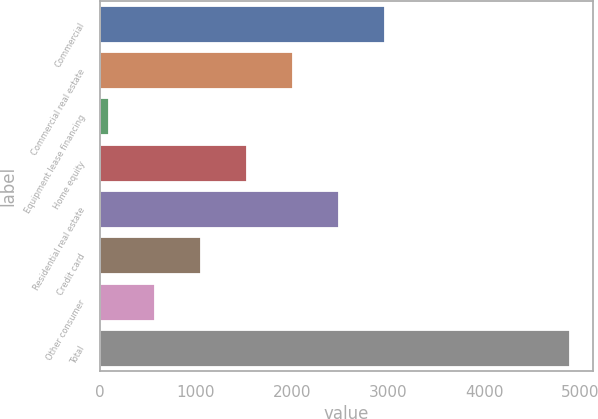Convert chart to OTSL. <chart><loc_0><loc_0><loc_500><loc_500><bar_chart><fcel>Commercial<fcel>Commercial real estate<fcel>Equipment lease financing<fcel>Home equity<fcel>Residential real estate<fcel>Credit card<fcel>Other consumer<fcel>Total<nl><fcel>2969.8<fcel>2011.2<fcel>94<fcel>1531.9<fcel>2490.5<fcel>1052.6<fcel>573.3<fcel>4887<nl></chart> 